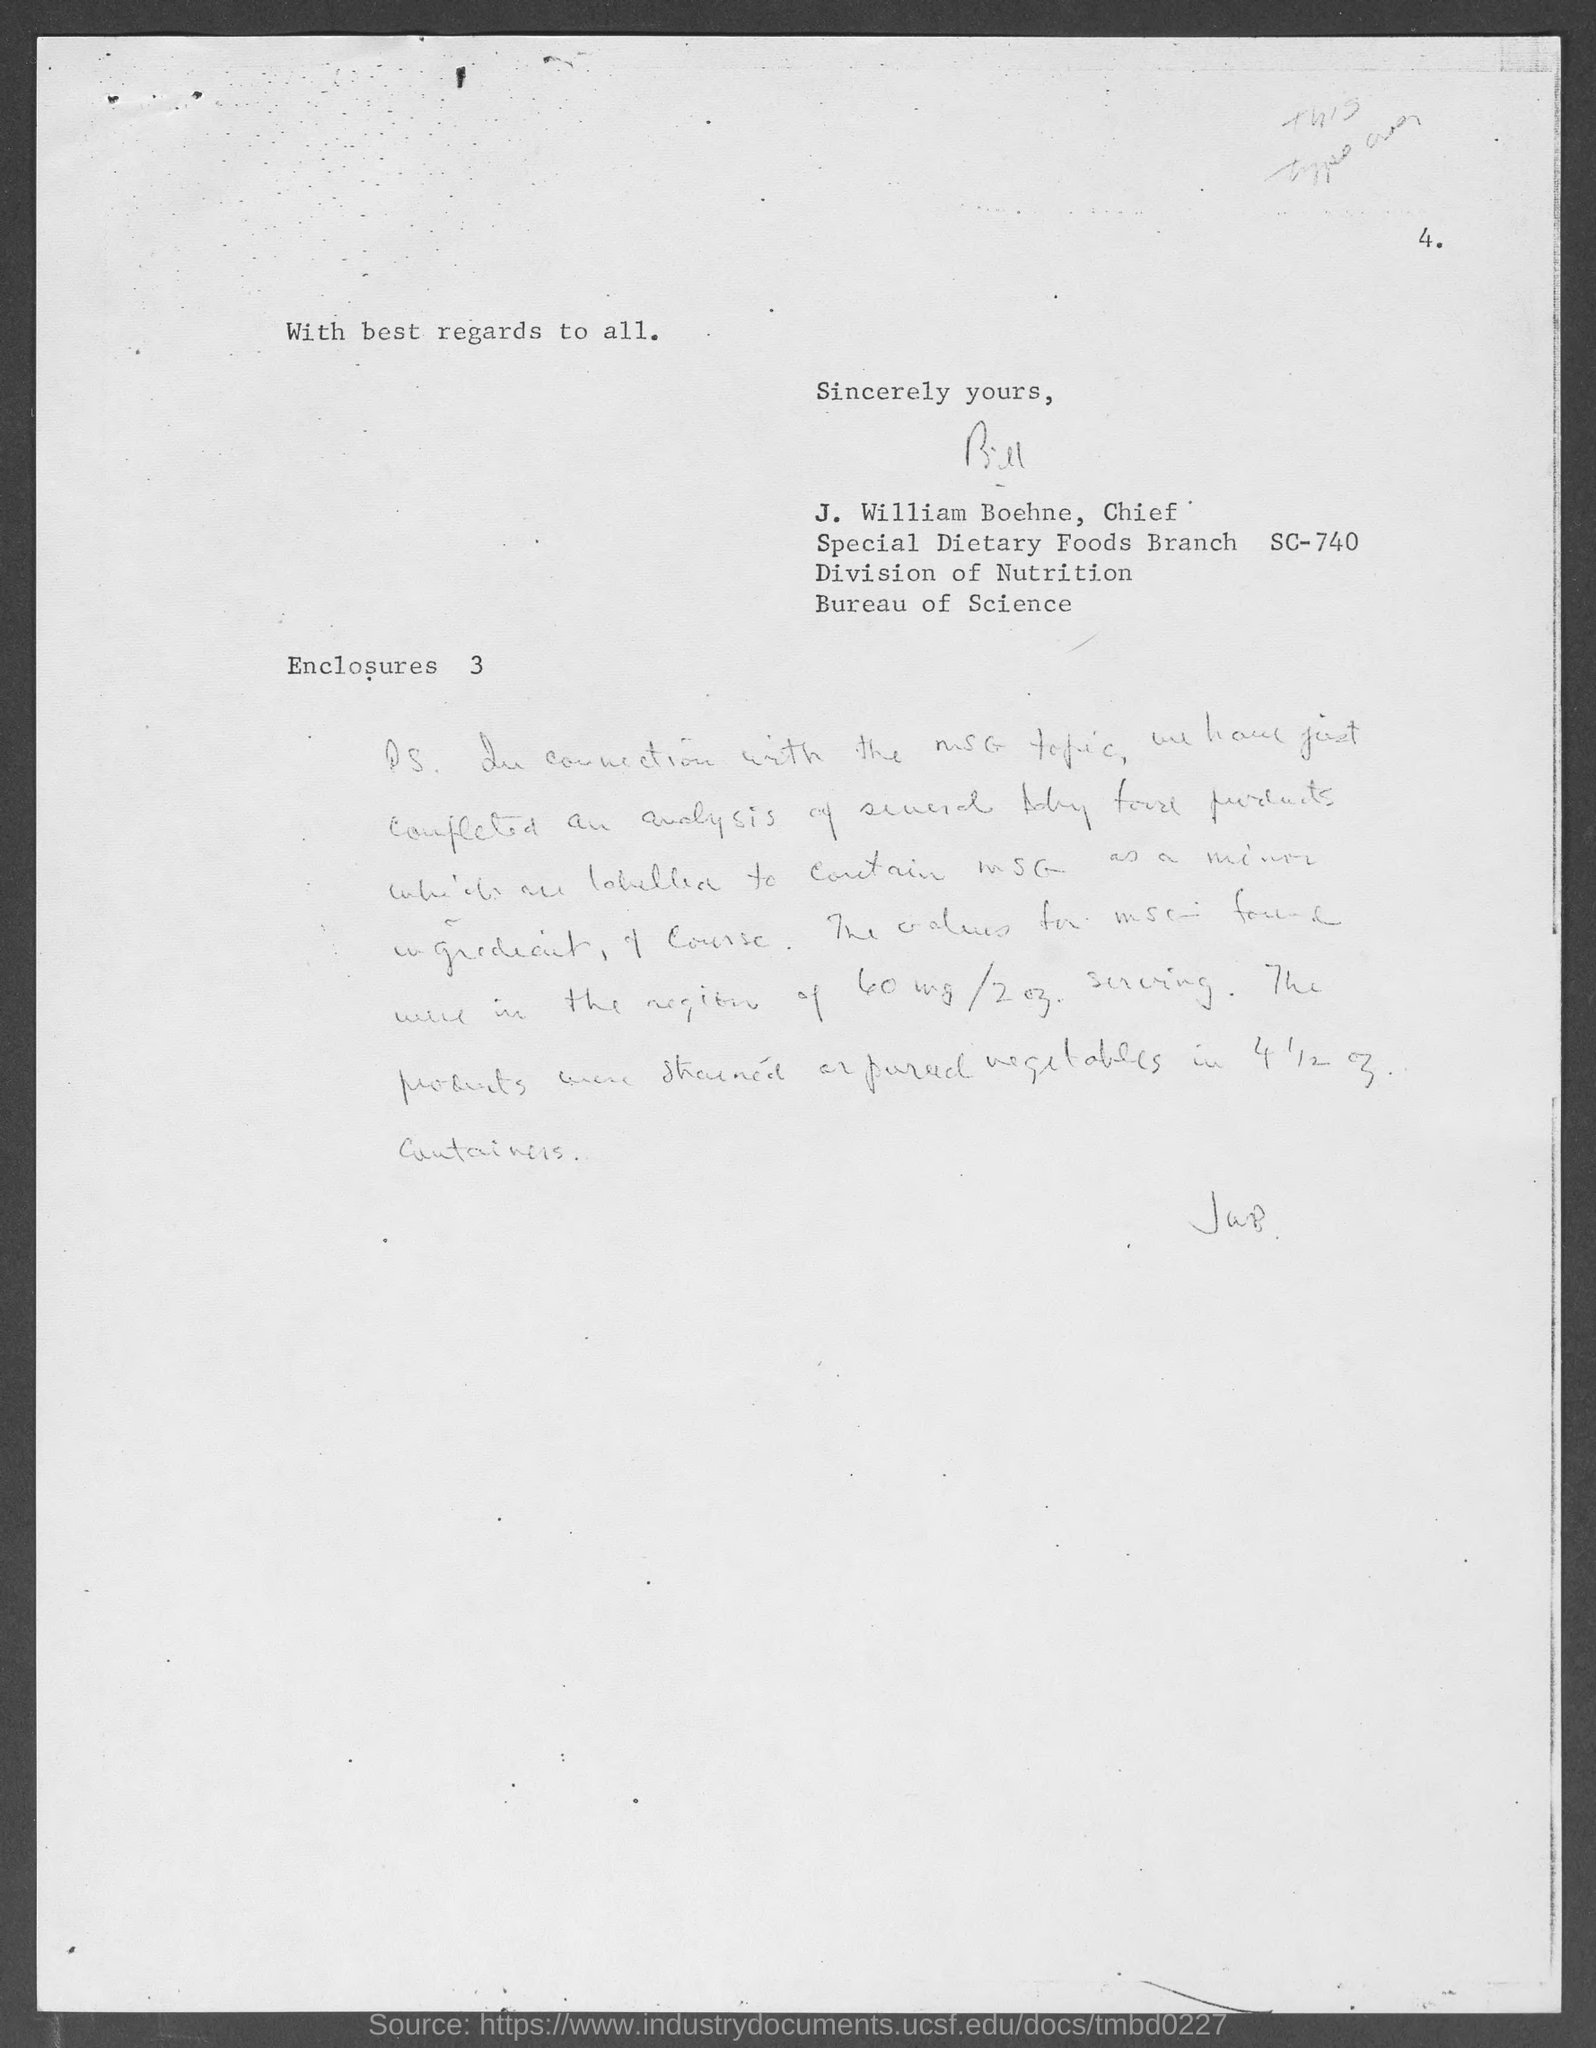Who is the chief, special dietary foods branch sc-740, division of nutrition, bureau of science ?
Give a very brief answer. J. William Boehne. 